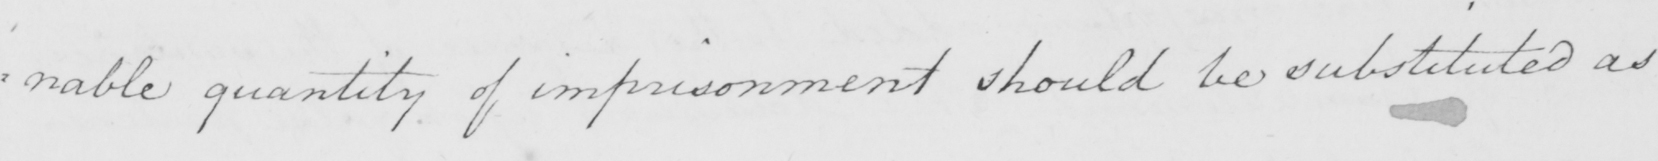Can you tell me what this handwritten text says? : nable quantity of imprisonment should be substituted as 